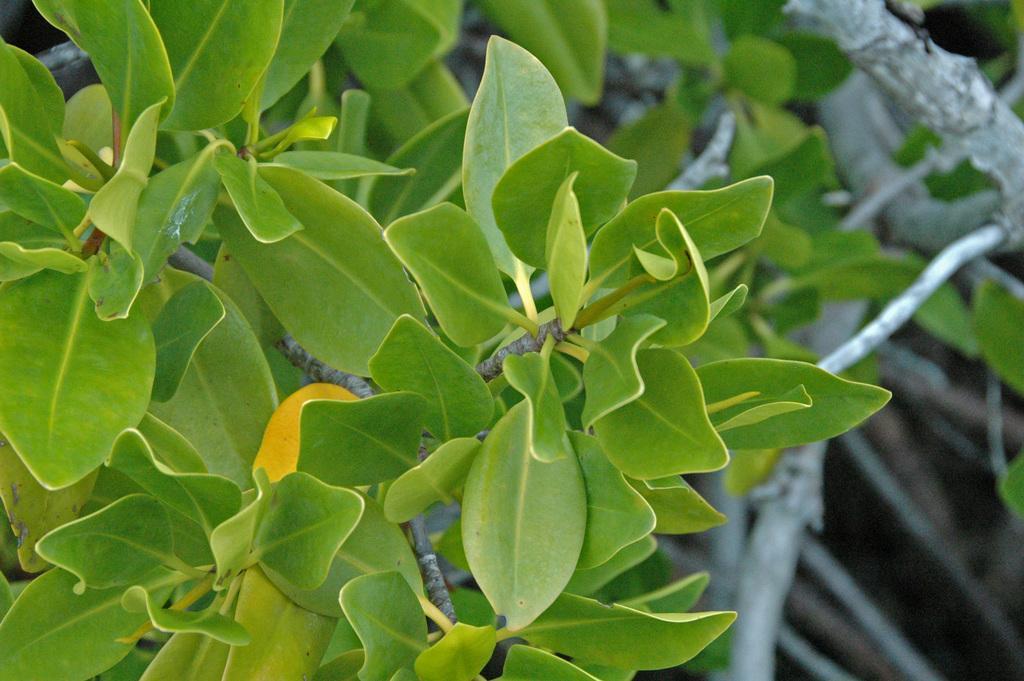How would you summarize this image in a sentence or two? In this image I can see on the left side there are green plants in this image. 